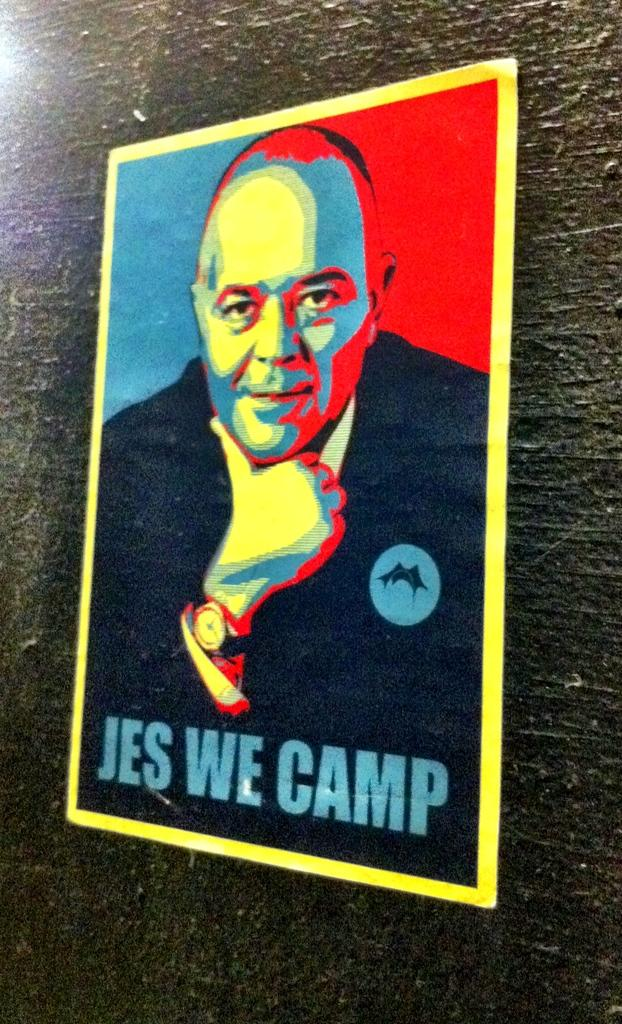What color is the wall in the image? The wall in the image is black colored. What is attached to the wall? There is a poster attached to the wall. What can be seen on the poster? The poster contains a picture of a person. Are there any words on the poster? Yes, there is text written on the poster. What type of note can be seen hanging from the person's trousers in the image? There is no person or trousers present in the image, and therefore no note can be seen hanging from them. 